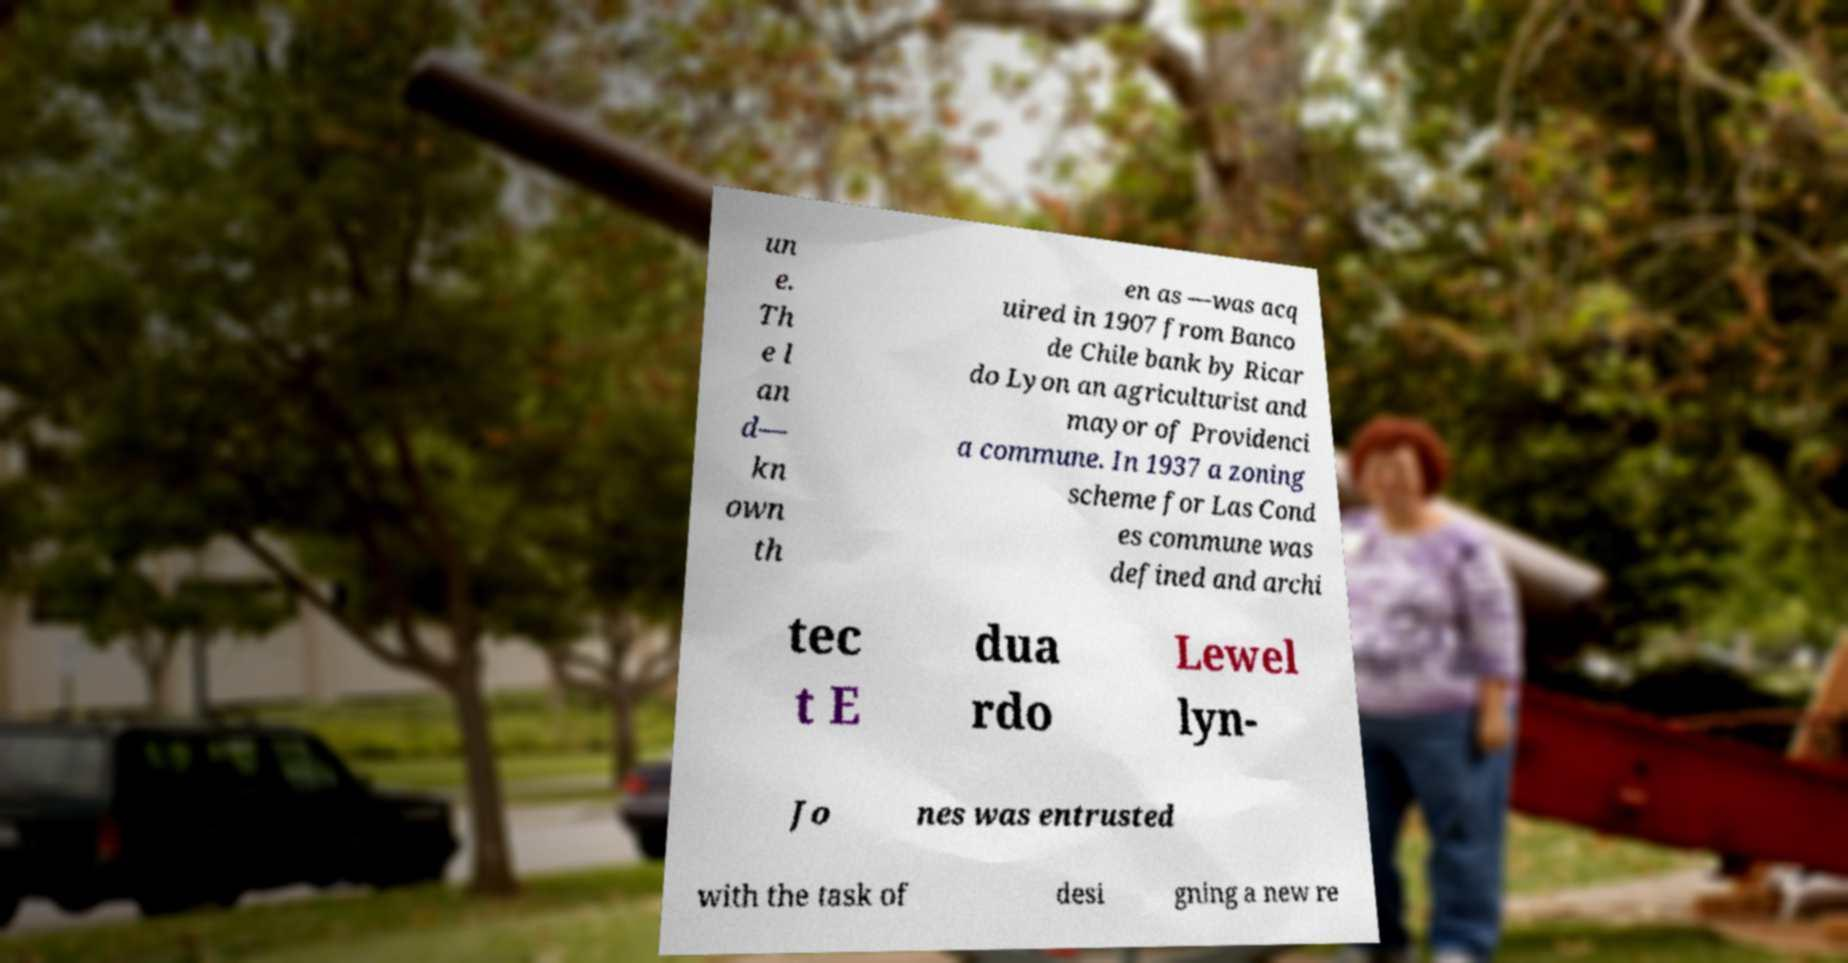For documentation purposes, I need the text within this image transcribed. Could you provide that? un e. Th e l an d— kn own th en as —was acq uired in 1907 from Banco de Chile bank by Ricar do Lyon an agriculturist and mayor of Providenci a commune. In 1937 a zoning scheme for Las Cond es commune was defined and archi tec t E dua rdo Lewel lyn- Jo nes was entrusted with the task of desi gning a new re 